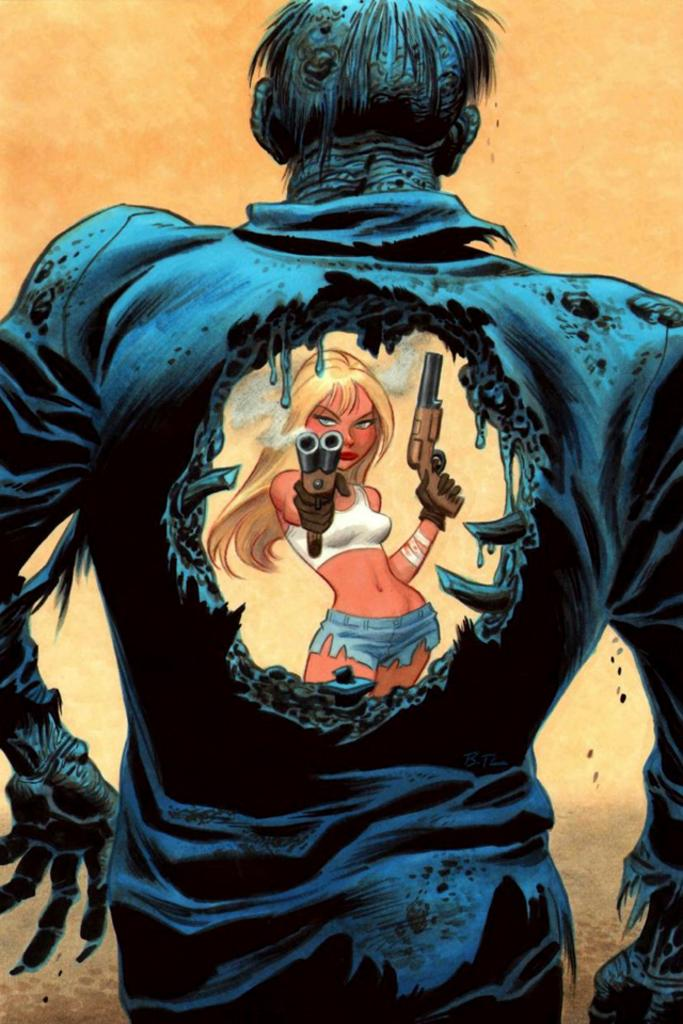What is the person holding in the image? The person is holding guns in the image. Can you describe the position of the other person in relation to the person holding guns? There is another person in front of the person holding guns. What type of mist can be seen surrounding the geese in the image? There are no geese or mist present in the image; it only features two people, one holding guns. 